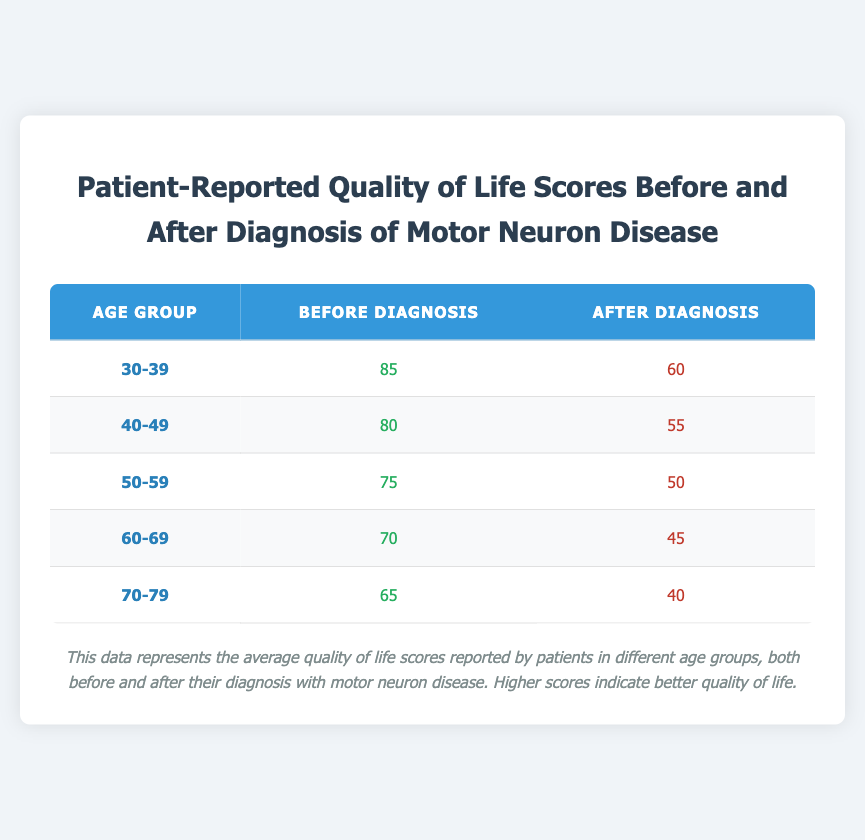What was the quality of life score for the age group 50-59 before diagnosis? According to the table, the quality of life score for the age group 50-59 before diagnosis is found in the corresponding row under the "Before Diagnosis" column. The value is 75.
Answer: 75 What is the difference in quality of life scores after diagnosis between the age groups 30-39 and 40-49? The scores after diagnosis for these age groups are 60 (for 30-39) and 55 (for 40-49). To find the difference, we subtract the lower score from the higher score: 60 - 55 = 5.
Answer: 5 Is it true that any age group has a quality of life score above 80 before diagnosis? Looking at the "Before Diagnosis" column, the age groups are: 85 (30-39), 80 (40-49), 75 (50-59), 70 (60-69), and 65 (70-79). The values 85 and 80 are both above 80, which confirms that there are age groups with scores above 80.
Answer: Yes Which age group reported the lowest quality of life score after diagnosis? The "After Diagnosis" column will show the scores for each age group. The scores are 60, 55, 50, 45, and 40 for age groups 30-39, 40-49, 50-59, 60-69, and 70-79 respectively. The lowest score is 40 from the age group 70-79.
Answer: 70-79 What is the average quality of life score before diagnosis for all age groups? To find the average, we first sum the scores from the "Before Diagnosis" column: 85 + 80 + 75 + 70 + 65 = 375. Then, we divide by the number of age groups, which is 5: 375 / 5 = 75.
Answer: 75 What is the sum of quality of life scores after diagnosis for the age groups 60-69 and 70-79? We look at the "After Diagnosis" scores for these age groups: 45 for 60-69 and 40 for 70-79. Adding them together gives: 45 + 40 = 85.
Answer: 85 Did the quality of life score after diagnosis fall below 50 for any age group? By examining the "After Diagnosis" column for scores, we see the values are 60, 55, 50, 45, and 40. The scores 45 and 40 are both below 50, indicating that at least one age group scored below this threshold.
Answer: Yes What is the increase in the quality of life score from before to after diagnosis for the age group 40-49? For the age group 40-49, the score before diagnosis is 80, and after diagnosis it is 55. The change can be found by subtracting the after diagnosis score from the before diagnosis score: 80 - 55 = 25.
Answer: 25 